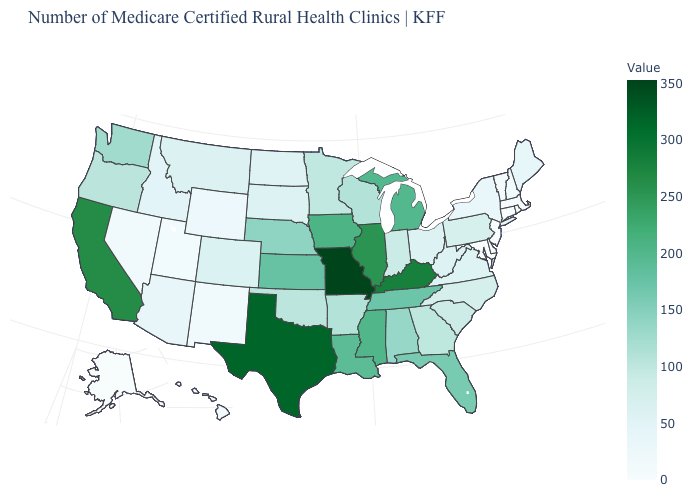Which states have the lowest value in the USA?
Write a very short answer. Alaska, Connecticut, Delaware, New Jersey, Rhode Island. Among the states that border Virginia , which have the lowest value?
Give a very brief answer. Maryland. Is the legend a continuous bar?
Keep it brief. Yes. Which states have the lowest value in the Northeast?
Quick response, please. Connecticut, New Jersey, Rhode Island. Does Alaska have the lowest value in the West?
Answer briefly. Yes. Which states hav the highest value in the MidWest?
Concise answer only. Missouri. Among the states that border New York , which have the highest value?
Keep it brief. Pennsylvania. Which states hav the highest value in the West?
Write a very short answer. California. Among the states that border Indiana , does Illinois have the highest value?
Write a very short answer. No. 